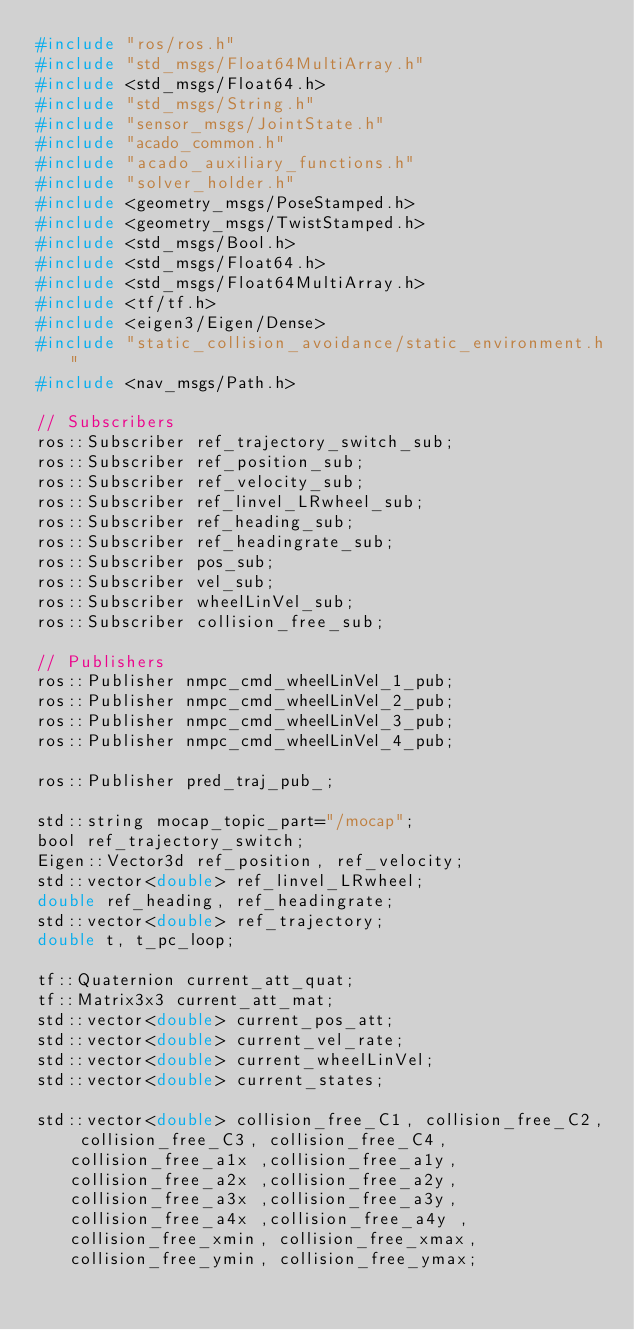<code> <loc_0><loc_0><loc_500><loc_500><_C_>#include "ros/ros.h"
#include "std_msgs/Float64MultiArray.h"
#include <std_msgs/Float64.h>
#include "std_msgs/String.h"
#include "sensor_msgs/JointState.h"
#include "acado_common.h"
#include "acado_auxiliary_functions.h"
#include "solver_holder.h"
#include <geometry_msgs/PoseStamped.h>
#include <geometry_msgs/TwistStamped.h>
#include <std_msgs/Bool.h>
#include <std_msgs/Float64.h>
#include <std_msgs/Float64MultiArray.h>
#include <tf/tf.h>
#include <eigen3/Eigen/Dense>
#include "static_collision_avoidance/static_environment.h"
#include <nav_msgs/Path.h>

// Subscribers
ros::Subscriber ref_trajectory_switch_sub;
ros::Subscriber ref_position_sub;
ros::Subscriber ref_velocity_sub;
ros::Subscriber ref_linvel_LRwheel_sub;
ros::Subscriber ref_heading_sub;
ros::Subscriber ref_headingrate_sub;
ros::Subscriber pos_sub;
ros::Subscriber vel_sub;
ros::Subscriber wheelLinVel_sub;
ros::Subscriber collision_free_sub;

// Publishers
ros::Publisher nmpc_cmd_wheelLinVel_1_pub;
ros::Publisher nmpc_cmd_wheelLinVel_2_pub;
ros::Publisher nmpc_cmd_wheelLinVel_3_pub;
ros::Publisher nmpc_cmd_wheelLinVel_4_pub;

ros::Publisher pred_traj_pub_;

std::string mocap_topic_part="/mocap";
bool ref_trajectory_switch;
Eigen::Vector3d ref_position, ref_velocity;
std::vector<double> ref_linvel_LRwheel;
double ref_heading, ref_headingrate;
std::vector<double> ref_trajectory;
double t, t_pc_loop;

tf::Quaternion current_att_quat;
tf::Matrix3x3 current_att_mat;
std::vector<double> current_pos_att;
std::vector<double> current_vel_rate;
std::vector<double> current_wheelLinVel;
std::vector<double> current_states;

std::vector<double> collision_free_C1, collision_free_C2, collision_free_C3, collision_free_C4, collision_free_a1x ,collision_free_a1y, collision_free_a2x ,collision_free_a2y, collision_free_a3x ,collision_free_a3y, collision_free_a4x ,collision_free_a4y , collision_free_xmin, collision_free_xmax, collision_free_ymin, collision_free_ymax;
</code> 